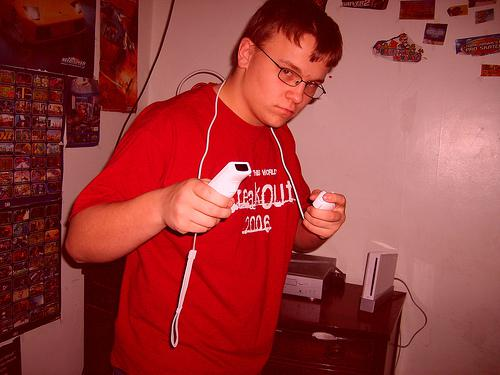Question: why is he holding the remote?
Choices:
A. To change the channel.
B. To turn down the volume on the TV.
C. To play the DVD.
D. To play the game.
Answer with the letter. Answer: D Question: what color is the shirt?
Choices:
A. Blue.
B. Red.
C. Black.
D. White.
Answer with the letter. Answer: B Question: who is in the picture?
Choices:
A. One man.
B. Three kids.
C. Two adults.
D. Five women.
Answer with the letter. Answer: A Question: where is he standing?
Choices:
A. By the table.
B. Next to the couch.
C. To the left of the stove.
D. In front of tv.
Answer with the letter. Answer: D Question: what is he holding?
Choices:
A. A gaming controller.
B. A laptop.
C. Remotes.
D. A cell phone.
Answer with the letter. Answer: C 